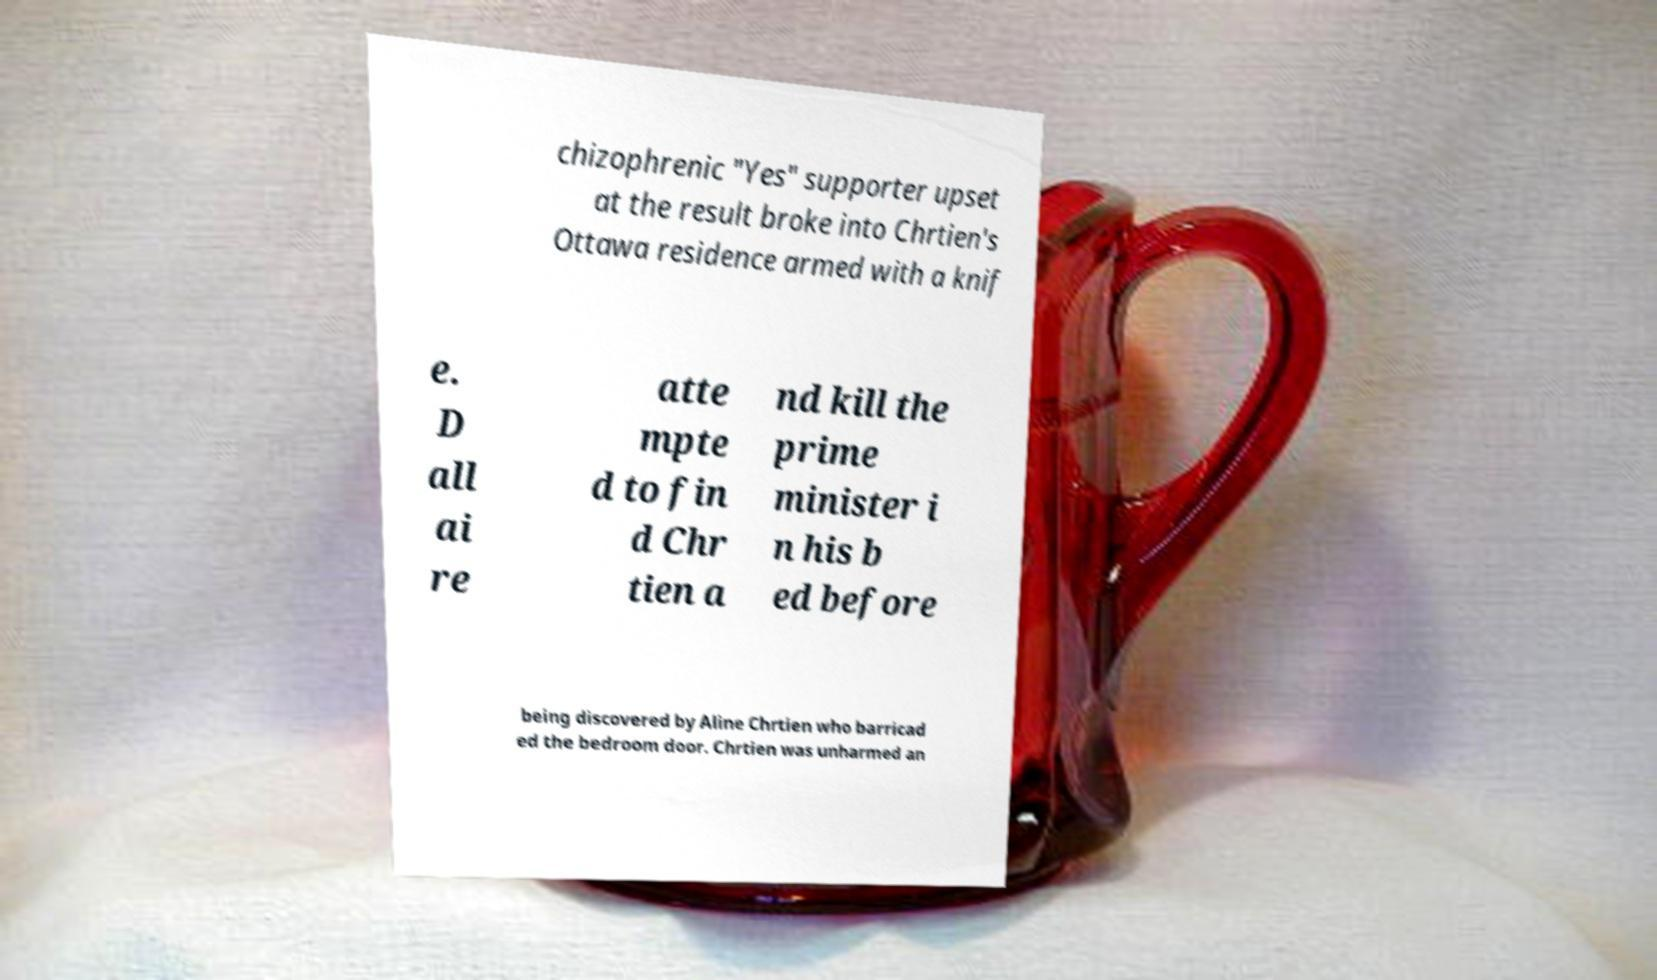Could you assist in decoding the text presented in this image and type it out clearly? chizophrenic "Yes" supporter upset at the result broke into Chrtien's Ottawa residence armed with a knif e. D all ai re atte mpte d to fin d Chr tien a nd kill the prime minister i n his b ed before being discovered by Aline Chrtien who barricad ed the bedroom door. Chrtien was unharmed an 